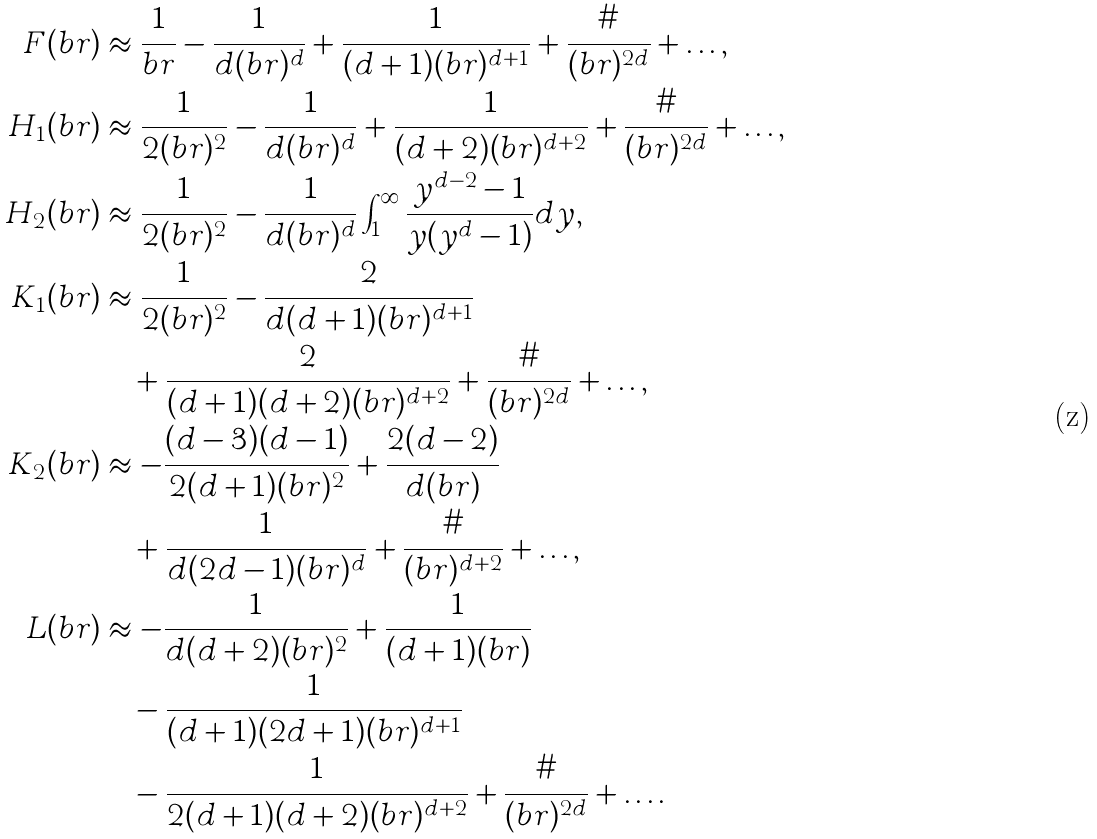Convert formula to latex. <formula><loc_0><loc_0><loc_500><loc_500>F ( b r ) & \approx \frac { 1 } { b r } - \frac { 1 } { d ( b r ) ^ { d } } + \frac { 1 } { ( d + 1 ) ( b r ) ^ { d + 1 } } + \frac { \# } { ( b r ) ^ { 2 d } } + \dots , \\ H _ { 1 } ( b r ) & \approx \frac { 1 } { 2 ( b r ) ^ { 2 } } - \frac { 1 } { d ( b r ) ^ { d } } + \frac { 1 } { ( d + 2 ) ( b r ) ^ { d + 2 } } + \frac { \# } { ( b r ) ^ { 2 d } } + \dots , \\ H _ { 2 } ( b r ) & \approx \frac { 1 } { 2 ( b r ) ^ { 2 } } - \frac { 1 } { d ( b r ) ^ { d } } \int _ { 1 } ^ { \infty } \frac { y ^ { d - 2 } - 1 } { y ( y ^ { d } - 1 ) } d y , \\ K _ { 1 } ( b r ) & \approx \frac { 1 } { 2 ( b r ) ^ { 2 } } - \frac { 2 } { d ( d + 1 ) ( b r ) ^ { d + 1 } } \\ & \quad + \frac { 2 } { ( d + 1 ) ( d + 2 ) ( b r ) ^ { d + 2 } } + \frac { \# } { ( b r ) ^ { 2 d } } + \dots , \\ K _ { 2 } ( b r ) & \approx - \frac { ( d - 3 ) ( d - 1 ) } { 2 ( d + 1 ) ( b r ) ^ { 2 } } + \frac { 2 ( d - 2 ) } { d ( b r ) } \\ & \quad + \frac { 1 } { d ( 2 d - 1 ) ( b r ) ^ { d } } + \frac { \# } { ( b r ) ^ { d + 2 } } + \dots , \\ L ( b r ) & \approx - \frac { 1 } { d ( d + 2 ) ( b r ) ^ { 2 } } + \frac { 1 } { ( d + 1 ) ( b r ) } \\ & \quad - \frac { 1 } { ( d + 1 ) ( 2 d + 1 ) ( b r ) ^ { d + 1 } } \\ & \quad - \frac { 1 } { 2 ( d + 1 ) ( d + 2 ) ( b r ) ^ { d + 2 } } + \frac { \# } { ( b r ) ^ { 2 d } } + \dots .</formula> 